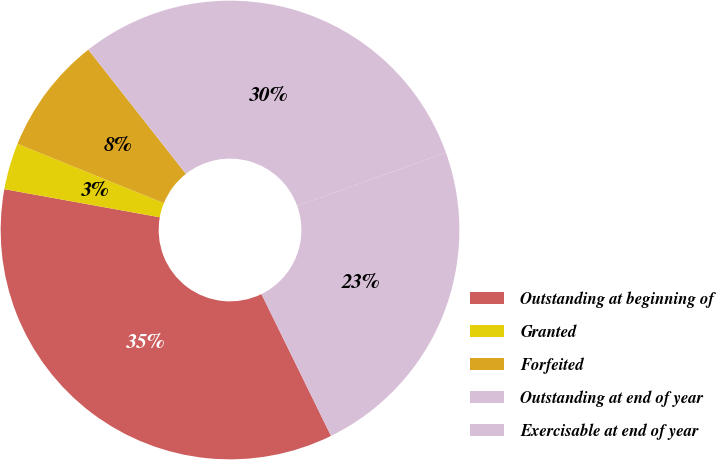<chart> <loc_0><loc_0><loc_500><loc_500><pie_chart><fcel>Outstanding at beginning of<fcel>Granted<fcel>Forfeited<fcel>Outstanding at end of year<fcel>Exercisable at end of year<nl><fcel>35.11%<fcel>3.28%<fcel>8.27%<fcel>30.12%<fcel>23.22%<nl></chart> 